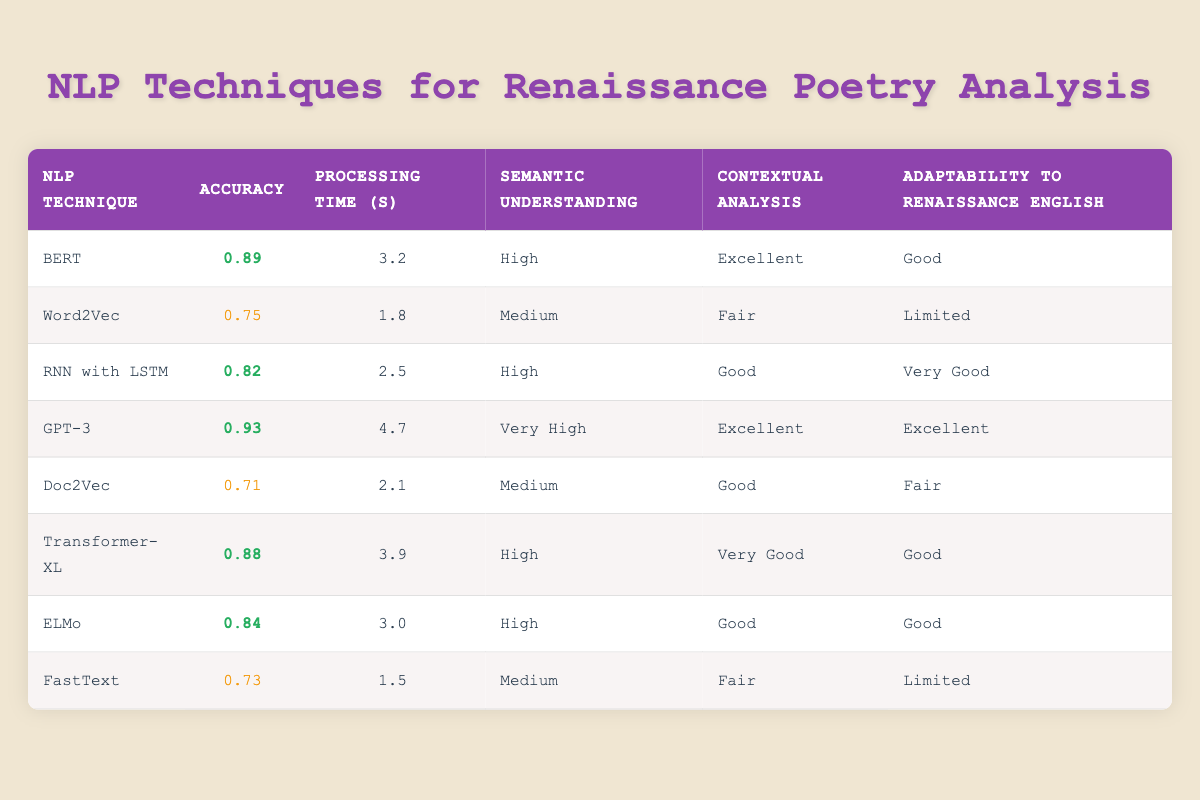What is the accuracy of GPT-3? According to the table, the accuracy of GPT-3 is listed as 0.93.
Answer: 0.93 Which NLP technique has the lowest accuracy? By scanning the accuracy column of the rows, Doc2Vec has the lowest accuracy value of 0.71.
Answer: 0.71 What is the processing time of FastText? The processing time for FastText, as seen in the table, is 1.5 seconds.
Answer: 1.5 seconds Is the semantic understanding provided by Word2Vec high? No, the table indicates that the semantic understanding for Word2Vec is classified as medium, not high.
Answer: No Which NLP techniques have excellent contextual analysis? The techniques that have excellent contextual analysis, as per the table, are GPT-3 and BERT.
Answer: GPT-3 and BERT What is the average accuracy of the methods that have high semantic understanding? The methods with high semantic understanding are BERT, RNN with LSTM, GPT-3, ELMo, and Transformer-XL. Their respective accuracies are 0.89, 0.82, 0.93, 0.84, and 0.88. The sum is 4.36, and dividing by 5 gives an average of 0.872.
Answer: 0.872 How many techniques have a processing time of less than 3 seconds? Scanning through the processing times shows that Word2Vec (1.8), FastText (1.5), and RNN with LSTM (2.5) each have processing times below 3 seconds. That amounts to three techniques.
Answer: 3 Which technique is the most adaptable to Renaissance English, and what is its accuracy? The technique with the highest adaptability to Renaissance English is GPT-3, with an accuracy of 0.93.
Answer: GPT-3, accuracy 0.93 Does any technique score "very high" in semantic understanding? Yes, GPT-3 scores "very high" in semantic understanding according to the table.
Answer: Yes 